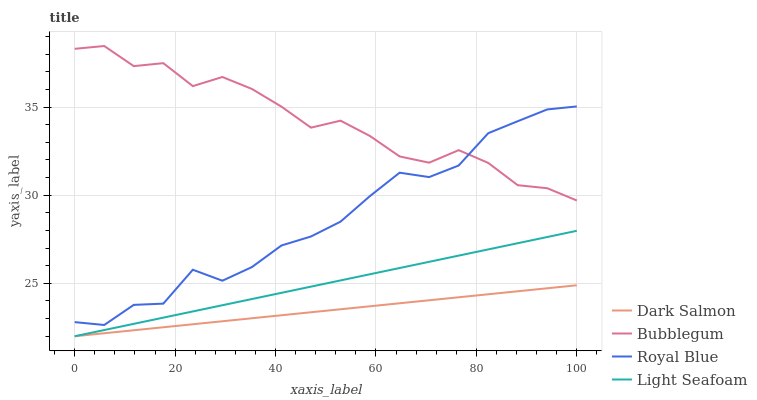Does Dark Salmon have the minimum area under the curve?
Answer yes or no. Yes. Does Bubblegum have the maximum area under the curve?
Answer yes or no. Yes. Does Light Seafoam have the minimum area under the curve?
Answer yes or no. No. Does Light Seafoam have the maximum area under the curve?
Answer yes or no. No. Is Light Seafoam the smoothest?
Answer yes or no. Yes. Is Bubblegum the roughest?
Answer yes or no. Yes. Is Dark Salmon the smoothest?
Answer yes or no. No. Is Dark Salmon the roughest?
Answer yes or no. No. Does Light Seafoam have the lowest value?
Answer yes or no. Yes. Does Bubblegum have the lowest value?
Answer yes or no. No. Does Bubblegum have the highest value?
Answer yes or no. Yes. Does Light Seafoam have the highest value?
Answer yes or no. No. Is Dark Salmon less than Royal Blue?
Answer yes or no. Yes. Is Royal Blue greater than Dark Salmon?
Answer yes or no. Yes. Does Light Seafoam intersect Dark Salmon?
Answer yes or no. Yes. Is Light Seafoam less than Dark Salmon?
Answer yes or no. No. Is Light Seafoam greater than Dark Salmon?
Answer yes or no. No. Does Dark Salmon intersect Royal Blue?
Answer yes or no. No. 